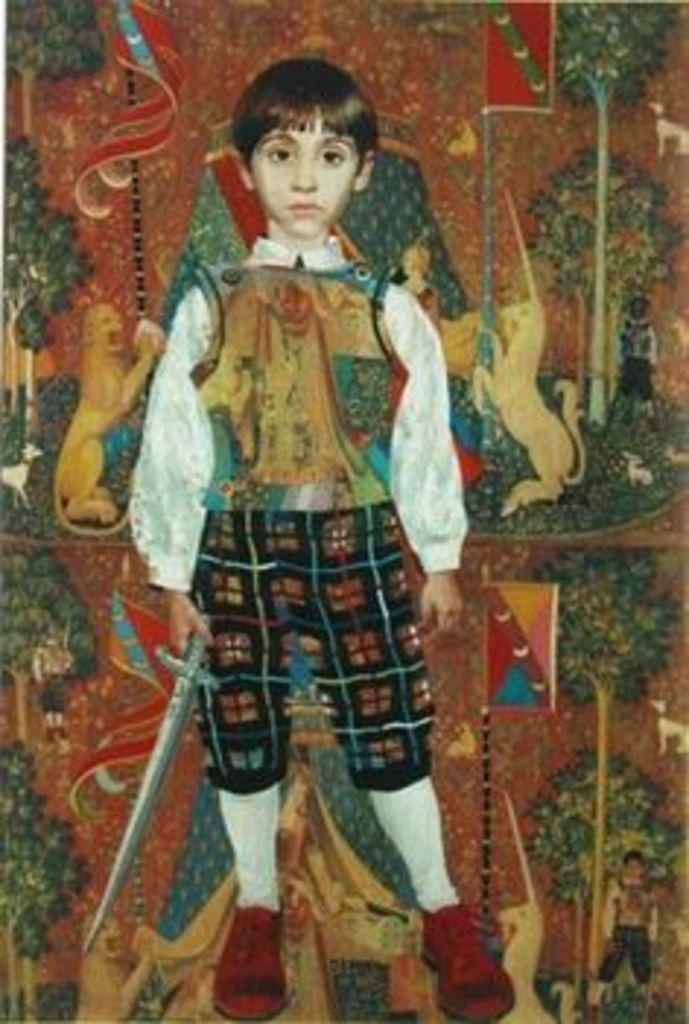What is the main subject of the painting in the image? There is a painting of a boy holding a sword in the image. What other subjects can be seen in the paintings in the image? There are paintings of animals and trees in the image. Are there any other paintings with specific objects in the image? Yes, there is a painting of a flag in the image. What type of juice can be seen in the painting of the boy holding a sword? There is no juice present in the painting of the boy holding a sword; it is a painting of a boy holding a sword. 